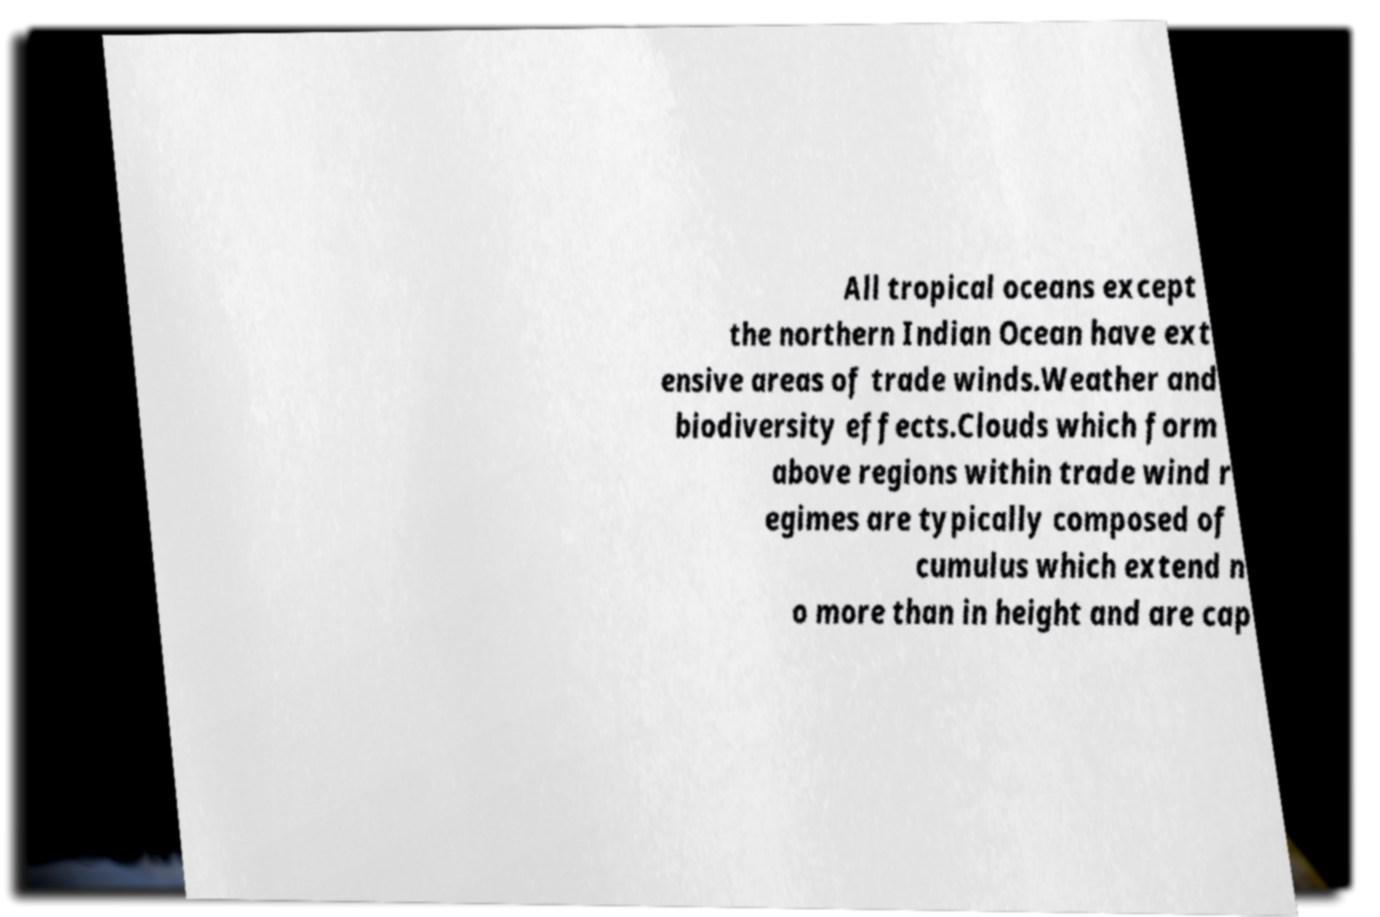Can you accurately transcribe the text from the provided image for me? All tropical oceans except the northern Indian Ocean have ext ensive areas of trade winds.Weather and biodiversity effects.Clouds which form above regions within trade wind r egimes are typically composed of cumulus which extend n o more than in height and are cap 